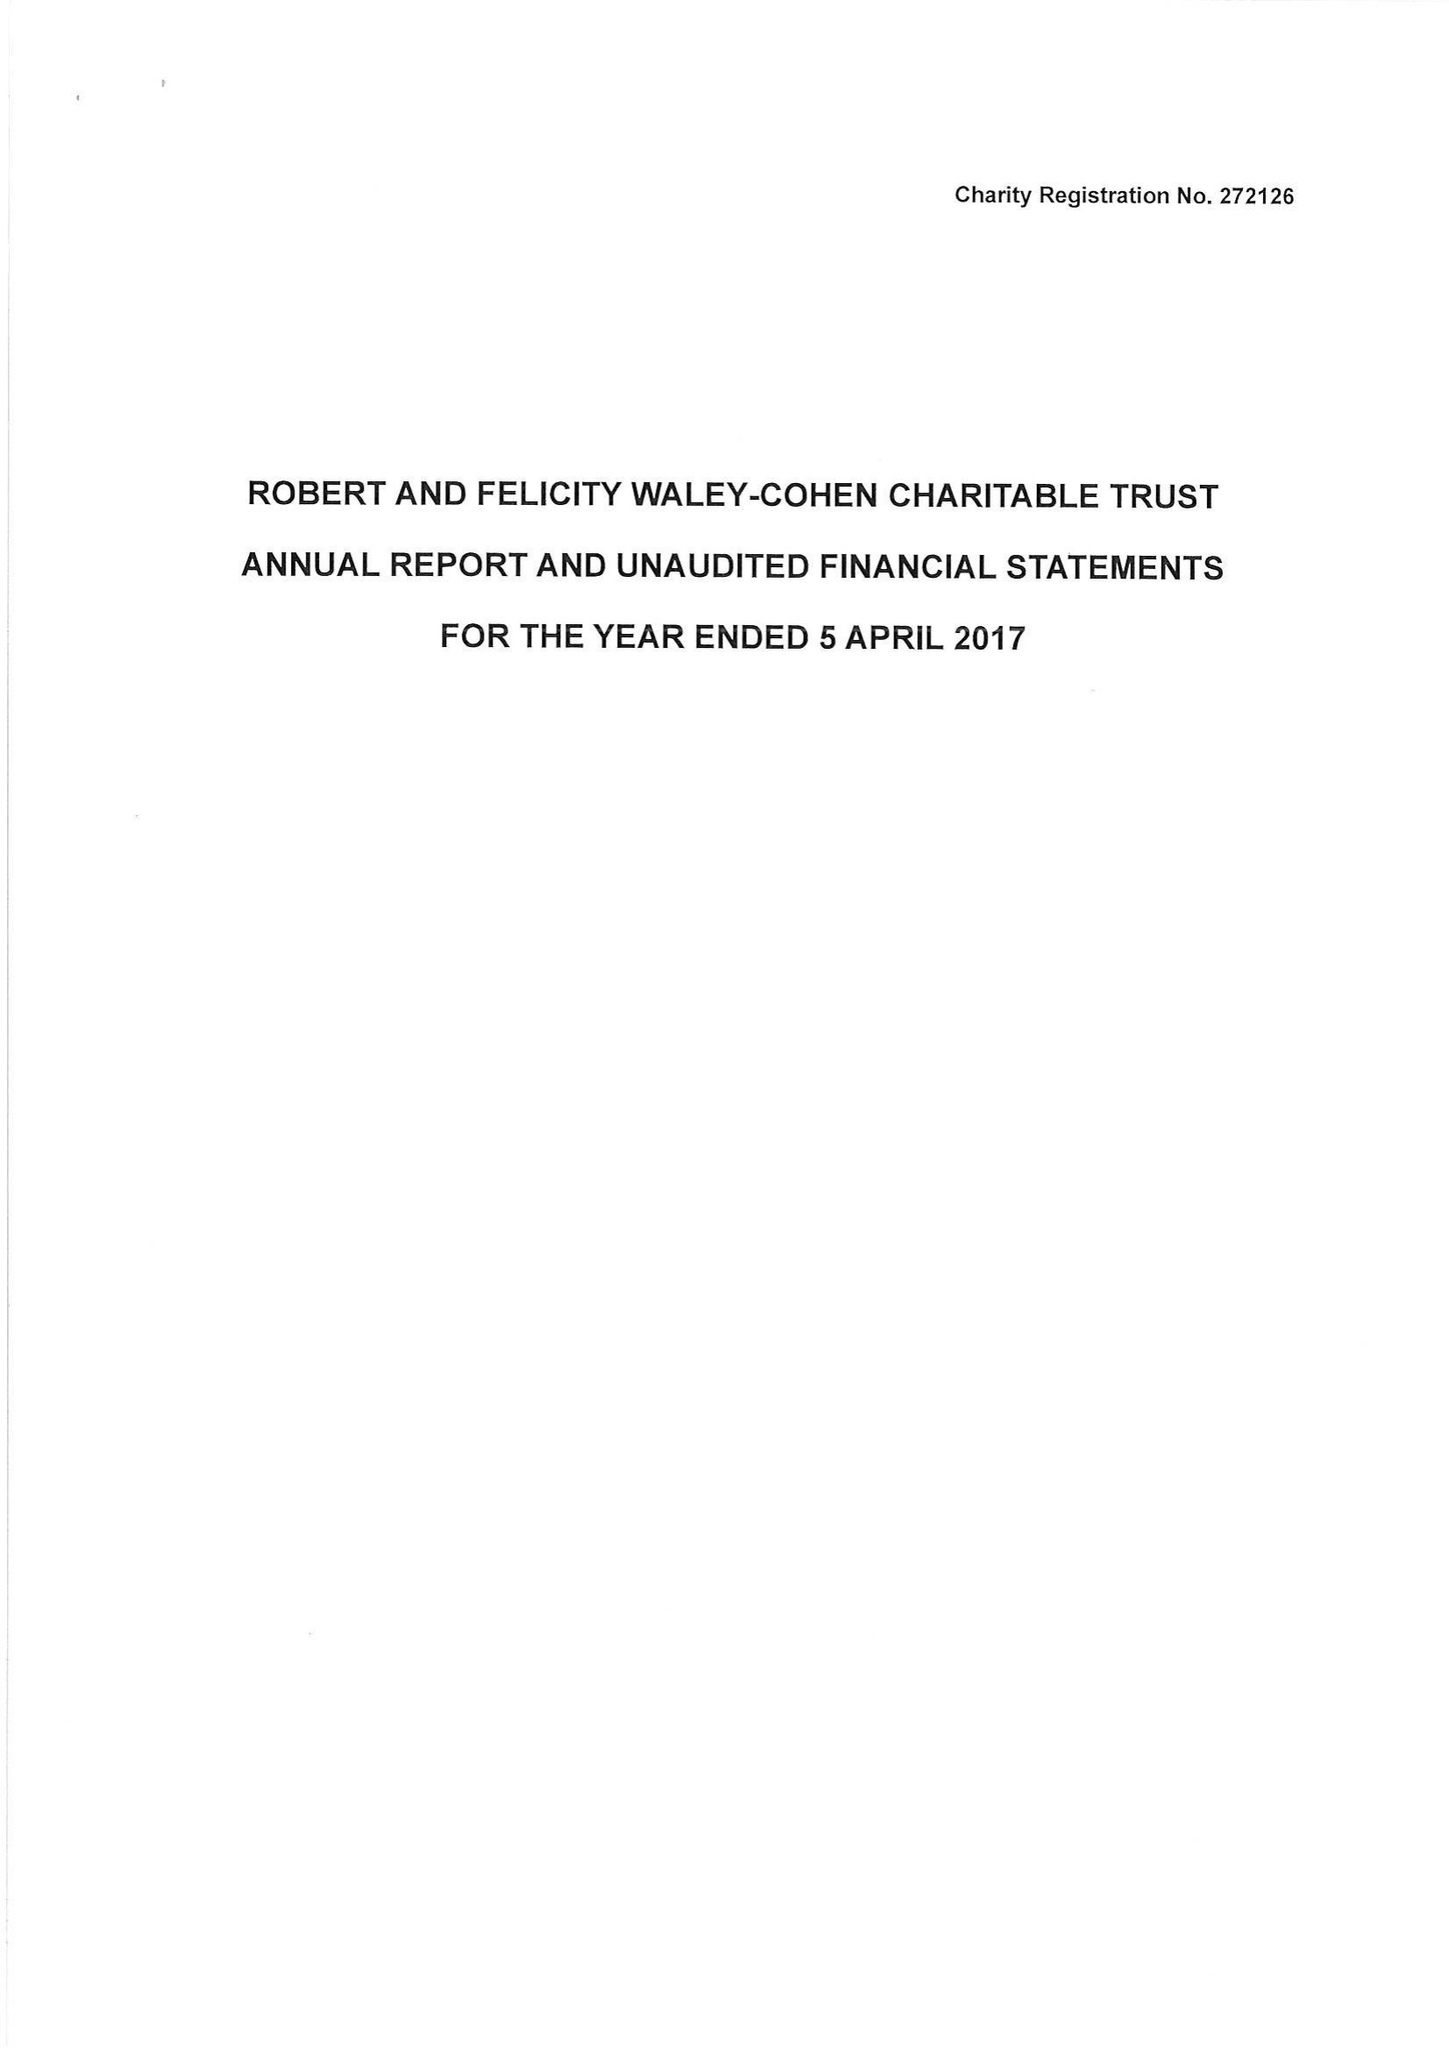What is the value for the address__post_town?
Answer the question using a single word or phrase. LONDON 